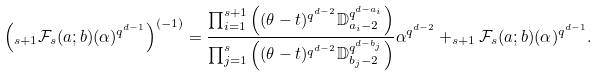<formula> <loc_0><loc_0><loc_500><loc_500>\left ( _ { s + 1 } \mathcal { F } _ { s } ( { a } ; { b } ) ( \alpha ) ^ { q ^ { d - 1 } } \right ) ^ { ( - 1 ) } = \frac { \prod _ { i = 1 } ^ { s + 1 } \left ( ( \theta - t ) ^ { q ^ { d - 2 } } \mathbb { D } _ { a _ { i } - 2 } ^ { q ^ { d - a _ { i } } } \right ) } { \prod _ { j = 1 } ^ { s } \left ( ( \theta - t ) ^ { q ^ { d - 2 } } \mathbb { D } _ { b _ { j } - 2 } ^ { q ^ { d - b _ { j } } } \right ) } \alpha ^ { q ^ { d - 2 } } + _ { s + 1 } \mathcal { F } _ { s } ( { a } ; { b } ) ( \alpha ) ^ { q ^ { d - 1 } } .</formula> 